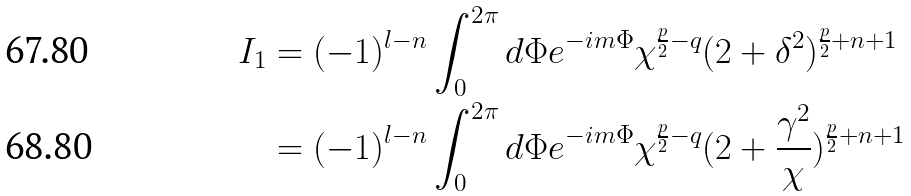<formula> <loc_0><loc_0><loc_500><loc_500>I _ { 1 } & = ( - 1 ) ^ { l - n } \int _ { 0 } ^ { 2 \pi } d \Phi e ^ { - i m \Phi } \chi ^ { \frac { p } { 2 } - q } ( 2 + \delta ^ { 2 } ) ^ { \frac { p } { 2 } + n + 1 } \\ & = ( - 1 ) ^ { l - n } \int _ { 0 } ^ { 2 \pi } d \Phi e ^ { - i m \Phi } \chi ^ { \frac { p } { 2 } - q } ( 2 + \frac { \gamma ^ { 2 } } { \chi } ) ^ { \frac { p } { 2 } + n + 1 }</formula> 